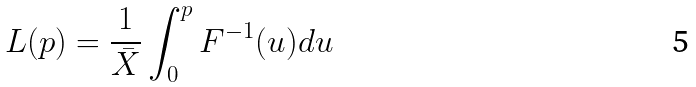Convert formula to latex. <formula><loc_0><loc_0><loc_500><loc_500>L ( p ) = \frac { 1 } { \bar { X } } \int _ { 0 } ^ { p } { F ^ { - 1 } ( u ) d u }</formula> 